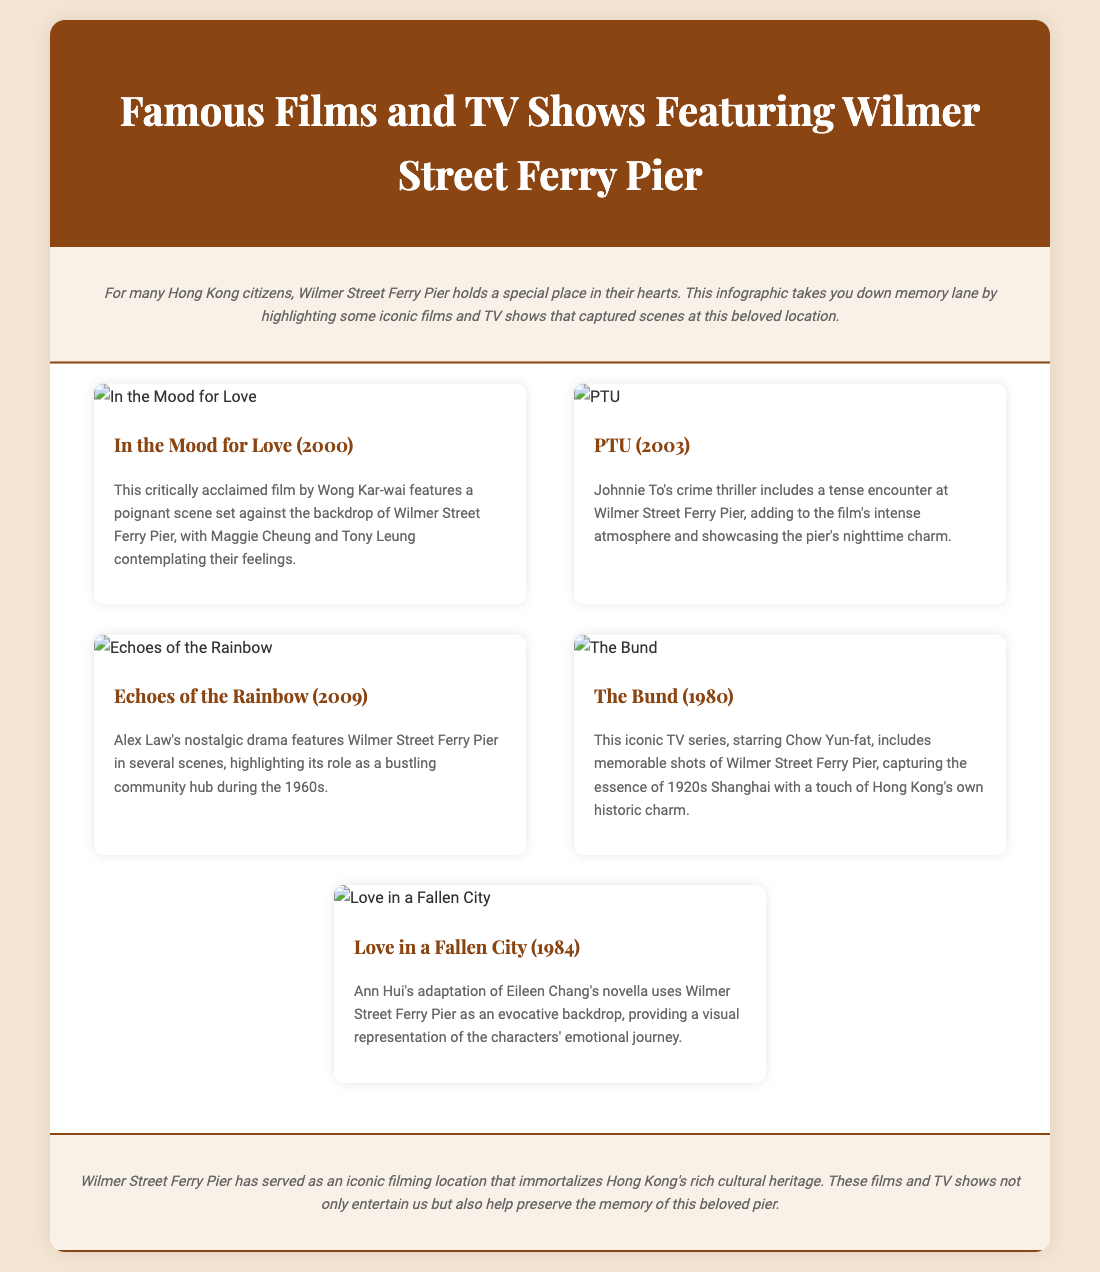what is the title of the first film listed? The first film listed in the document is "In the Mood for Love."
Answer: In the Mood for Love who directed "PTU"? The film "PTU" was directed by Johnnie To.
Answer: Johnnie To what year was "Echoes of the Rainbow" released? "Echoes of the Rainbow" was released in 2009, as stated in the document.
Answer: 2009 how many films and TV shows feature scenes at Wilmer Street Ferry Pier in the document? The document showcases a total of five films and TV shows featuring Wilmer Street Ferry Pier.
Answer: Five which actor starred in "The Bund"? Chow Yun-fat starred in the iconic TV series "The Bund."
Answer: Chow Yun-fat what is a common theme in the films listed? A common theme is the emotional or nostalgic representation of Hong Kong's history.
Answer: Nostalgia what specific aspect does the conclusion highlight about Wilmer Street Ferry Pier? The conclusion highlights that the pier serves as an iconic filming location preserving cultural heritage.
Answer: Cultural heritage which film adaptation uses Wilmer Street as a backdrop? "Love in a Fallen City" is an adaptation that uses Wilmer Street as a backdrop.
Answer: Love in a Fallen City what genre is the film "PTU"? "PTU" is classified as a crime thriller.
Answer: Crime thriller 